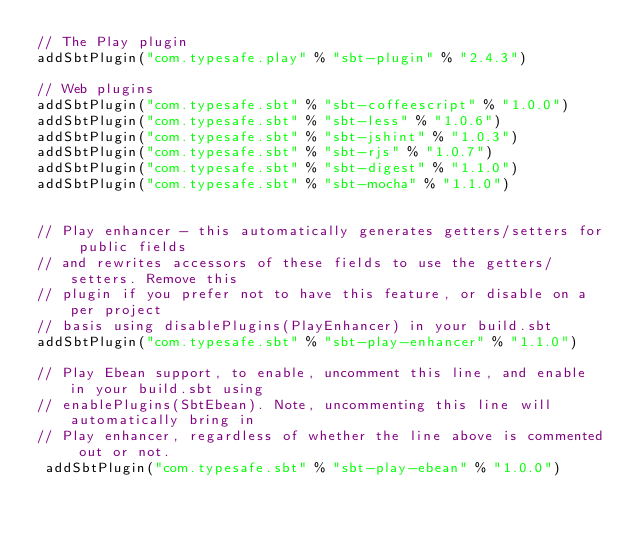Convert code to text. <code><loc_0><loc_0><loc_500><loc_500><_Scala_>// The Play plugin
addSbtPlugin("com.typesafe.play" % "sbt-plugin" % "2.4.3")

// Web plugins
addSbtPlugin("com.typesafe.sbt" % "sbt-coffeescript" % "1.0.0")
addSbtPlugin("com.typesafe.sbt" % "sbt-less" % "1.0.6")
addSbtPlugin("com.typesafe.sbt" % "sbt-jshint" % "1.0.3")
addSbtPlugin("com.typesafe.sbt" % "sbt-rjs" % "1.0.7")
addSbtPlugin("com.typesafe.sbt" % "sbt-digest" % "1.1.0")
addSbtPlugin("com.typesafe.sbt" % "sbt-mocha" % "1.1.0")


// Play enhancer - this automatically generates getters/setters for public fields
// and rewrites accessors of these fields to use the getters/setters. Remove this
// plugin if you prefer not to have this feature, or disable on a per project
// basis using disablePlugins(PlayEnhancer) in your build.sbt
addSbtPlugin("com.typesafe.sbt" % "sbt-play-enhancer" % "1.1.0")

// Play Ebean support, to enable, uncomment this line, and enable in your build.sbt using
// enablePlugins(SbtEbean). Note, uncommenting this line will automatically bring in
// Play enhancer, regardless of whether the line above is commented out or not.
 addSbtPlugin("com.typesafe.sbt" % "sbt-play-ebean" % "1.0.0")
</code> 